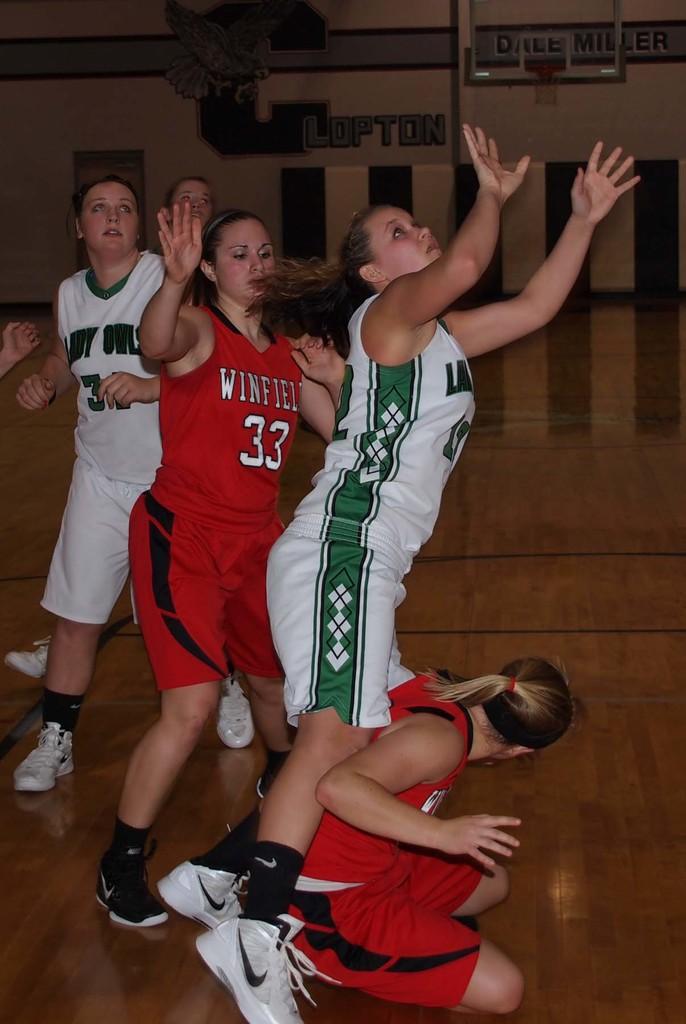What is the number of the player in the red jersey?
Provide a short and direct response. 33. 